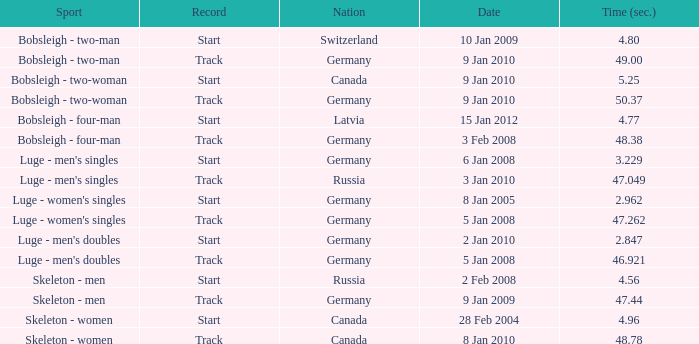In which sport does the time surpass 49? Bobsleigh - two-woman. 